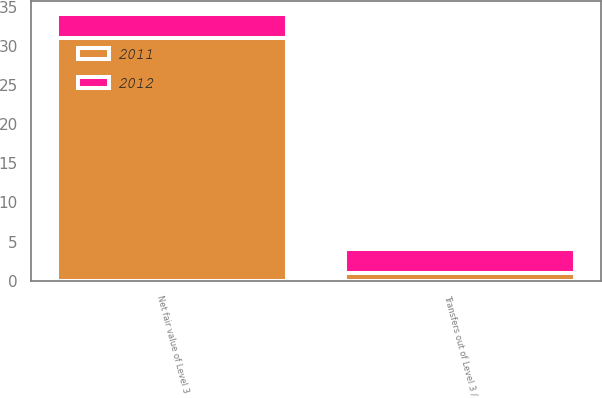Convert chart to OTSL. <chart><loc_0><loc_0><loc_500><loc_500><stacked_bar_chart><ecel><fcel>Transfers out of Level 3 /<fcel>Net fair value of Level 3<nl><fcel>2012<fcel>3<fcel>3<nl><fcel>2011<fcel>1<fcel>31<nl></chart> 